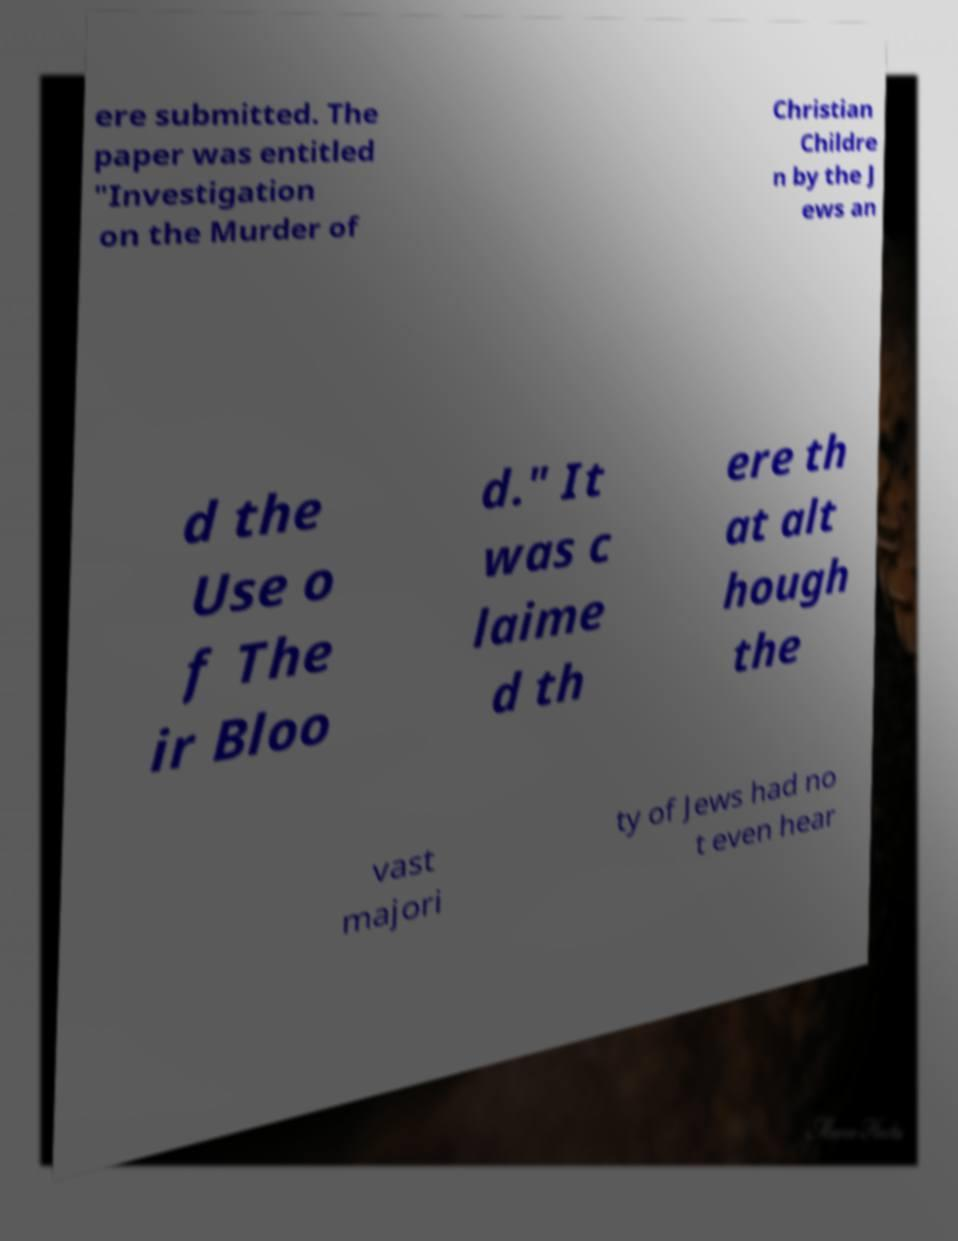There's text embedded in this image that I need extracted. Can you transcribe it verbatim? ere submitted. The paper was entitled "Investigation on the Murder of Christian Childre n by the J ews an d the Use o f The ir Bloo d." It was c laime d th ere th at alt hough the vast majori ty of Jews had no t even hear 